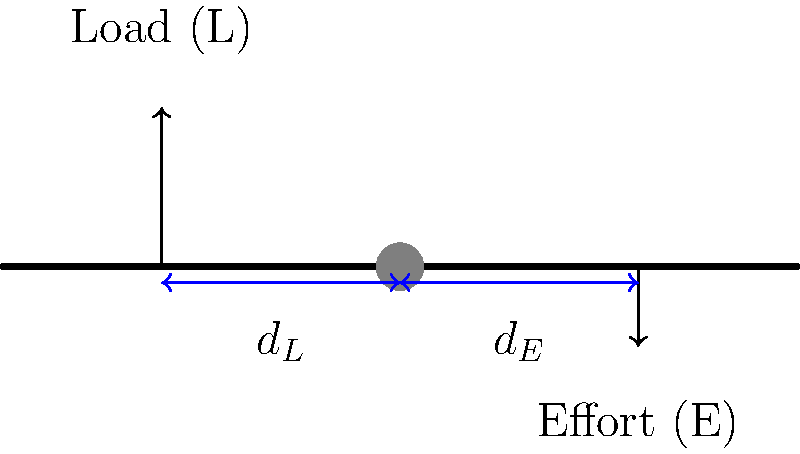In early farming equipment, levers were often used to lift heavy loads. Consider a lever used to lift a 500-pound hay bale. The load is placed 3 feet from the fulcrum, and a farmer applies an effort 7 feet from the fulcrum on the opposite side. How much force (in pounds) must the farmer apply to lift the hay bale? To solve this problem, we'll use the principle of moments for a lever in equilibrium:

1. The principle states that the sum of clockwise moments equals the sum of counterclockwise moments.

2. Moment = Force × Distance from fulcrum

3. Let's define our variables:
   $L$ = Load = 500 lbs
   $d_L$ = Distance of load from fulcrum = 3 ft
   $d_E$ = Distance of effort from fulcrum = 7 ft
   $E$ = Effort (force applied by farmer) = unknown

4. Set up the equation:
   $L \times d_L = E \times d_E$

5. Substitute known values:
   $500 \text{ lbs} \times 3 \text{ ft} = E \times 7 \text{ ft}$

6. Simplify:
   $1500 \text{ ft-lbs} = 7E \text{ ft-lbs}$

7. Solve for $E$:
   $E = \frac{1500 \text{ ft-lbs}}{7 \text{ ft}} = 214.29 \text{ lbs}$

8. Round to the nearest pound:
   $E \approx 214 \text{ lbs}$

Therefore, the farmer must apply approximately 214 pounds of force to lift the 500-pound hay bale using this lever arrangement.
Answer: 214 lbs 